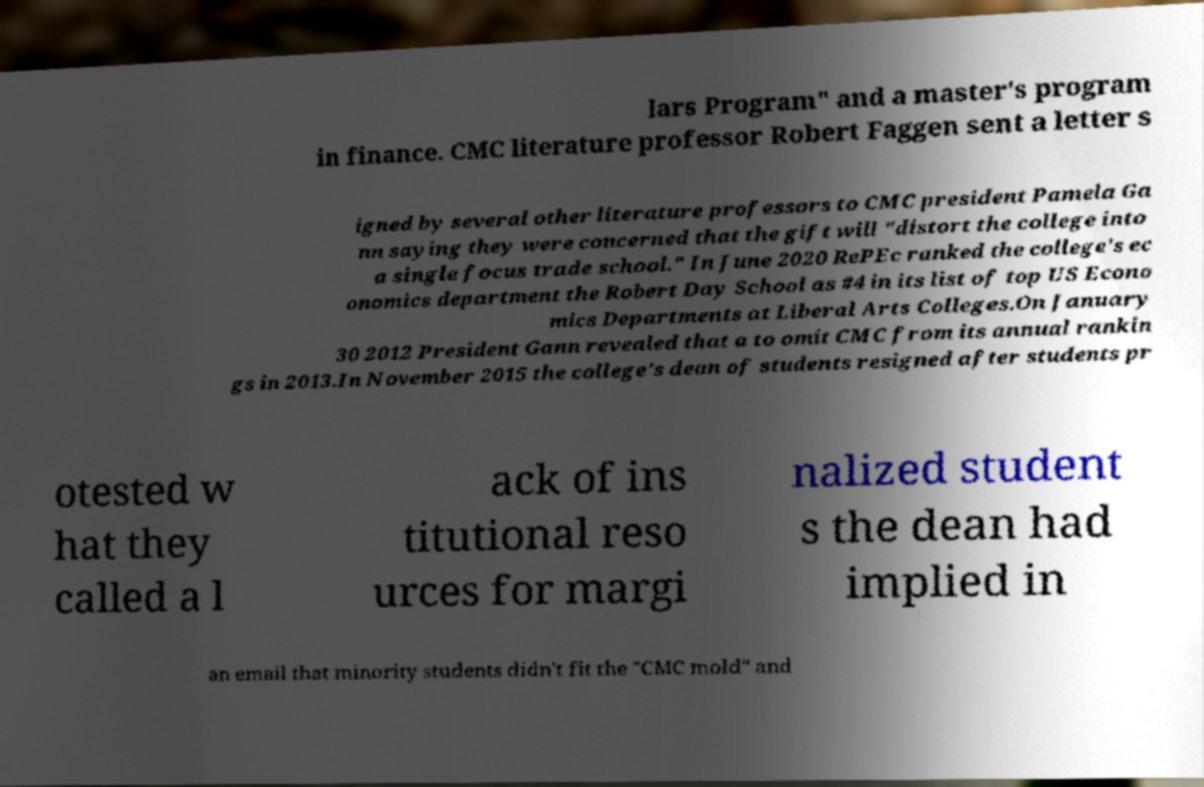There's text embedded in this image that I need extracted. Can you transcribe it verbatim? lars Program" and a master's program in finance. CMC literature professor Robert Faggen sent a letter s igned by several other literature professors to CMC president Pamela Ga nn saying they were concerned that the gift will "distort the college into a single focus trade school." In June 2020 RePEc ranked the college's ec onomics department the Robert Day School as #4 in its list of top US Econo mics Departments at Liberal Arts Colleges.On January 30 2012 President Gann revealed that a to omit CMC from its annual rankin gs in 2013.In November 2015 the college's dean of students resigned after students pr otested w hat they called a l ack of ins titutional reso urces for margi nalized student s the dean had implied in an email that minority students didn't fit the "CMC mold" and 